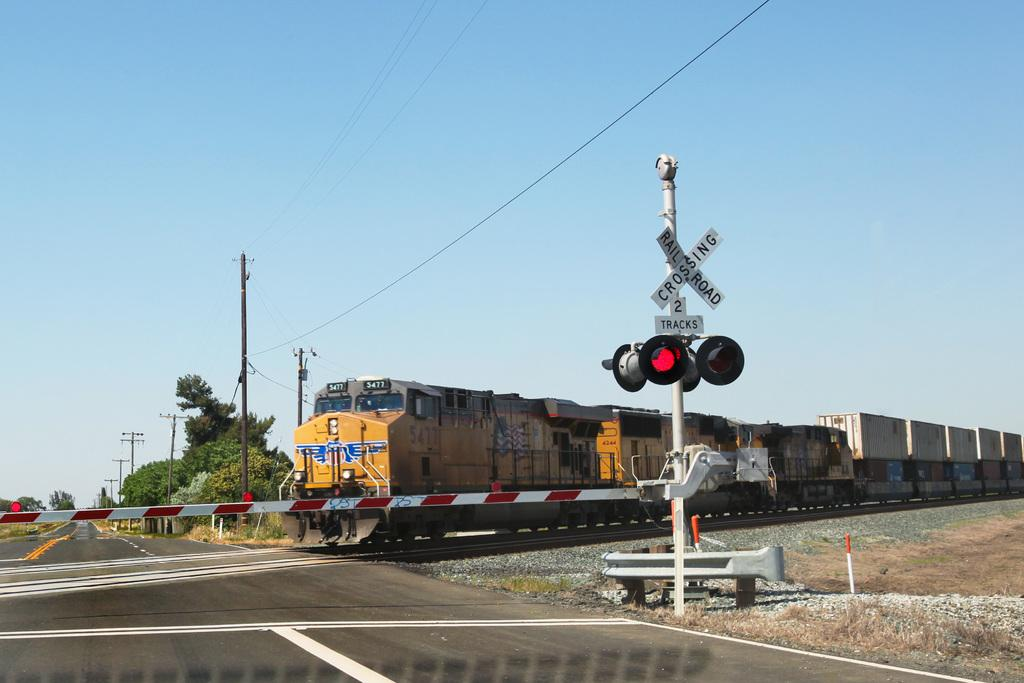Provide a one-sentence caption for the provided image. A railroad crossing sign says that there are two tracks at this spot. 